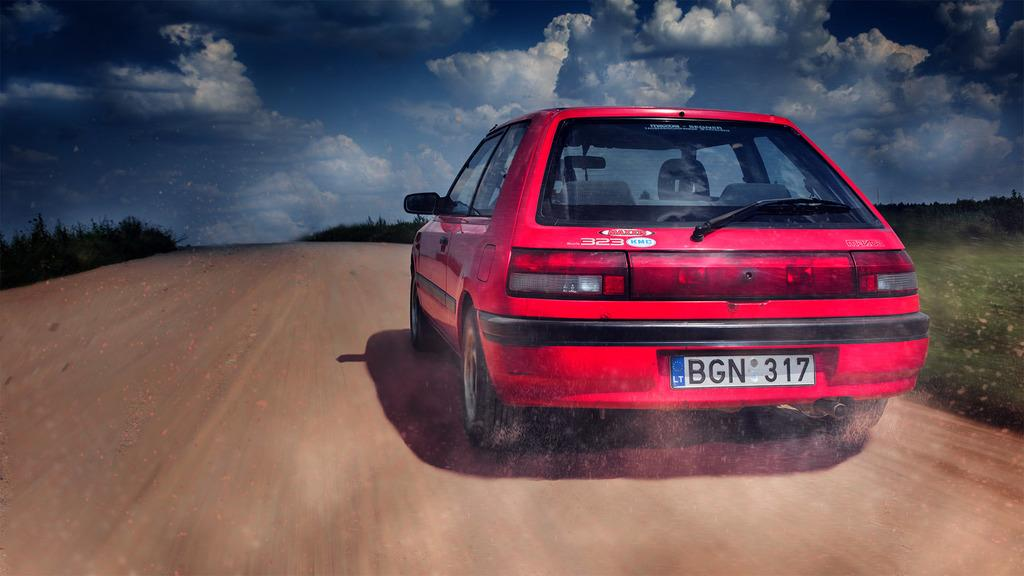What color is the car on the road in the image? The car on the road is red. What can be seen on the ground on the left side of the image? There are plants on the ground on the left side. What is present on the right side of the image? There are also plants on the right side. What is visible in the sky in the background of the image? There are clouds in the sky in the background. What type of coat is hanging on the tree in the image? There is no coat present in the image; it features a red car on the road with plants on both sides and clouds in the sky. 